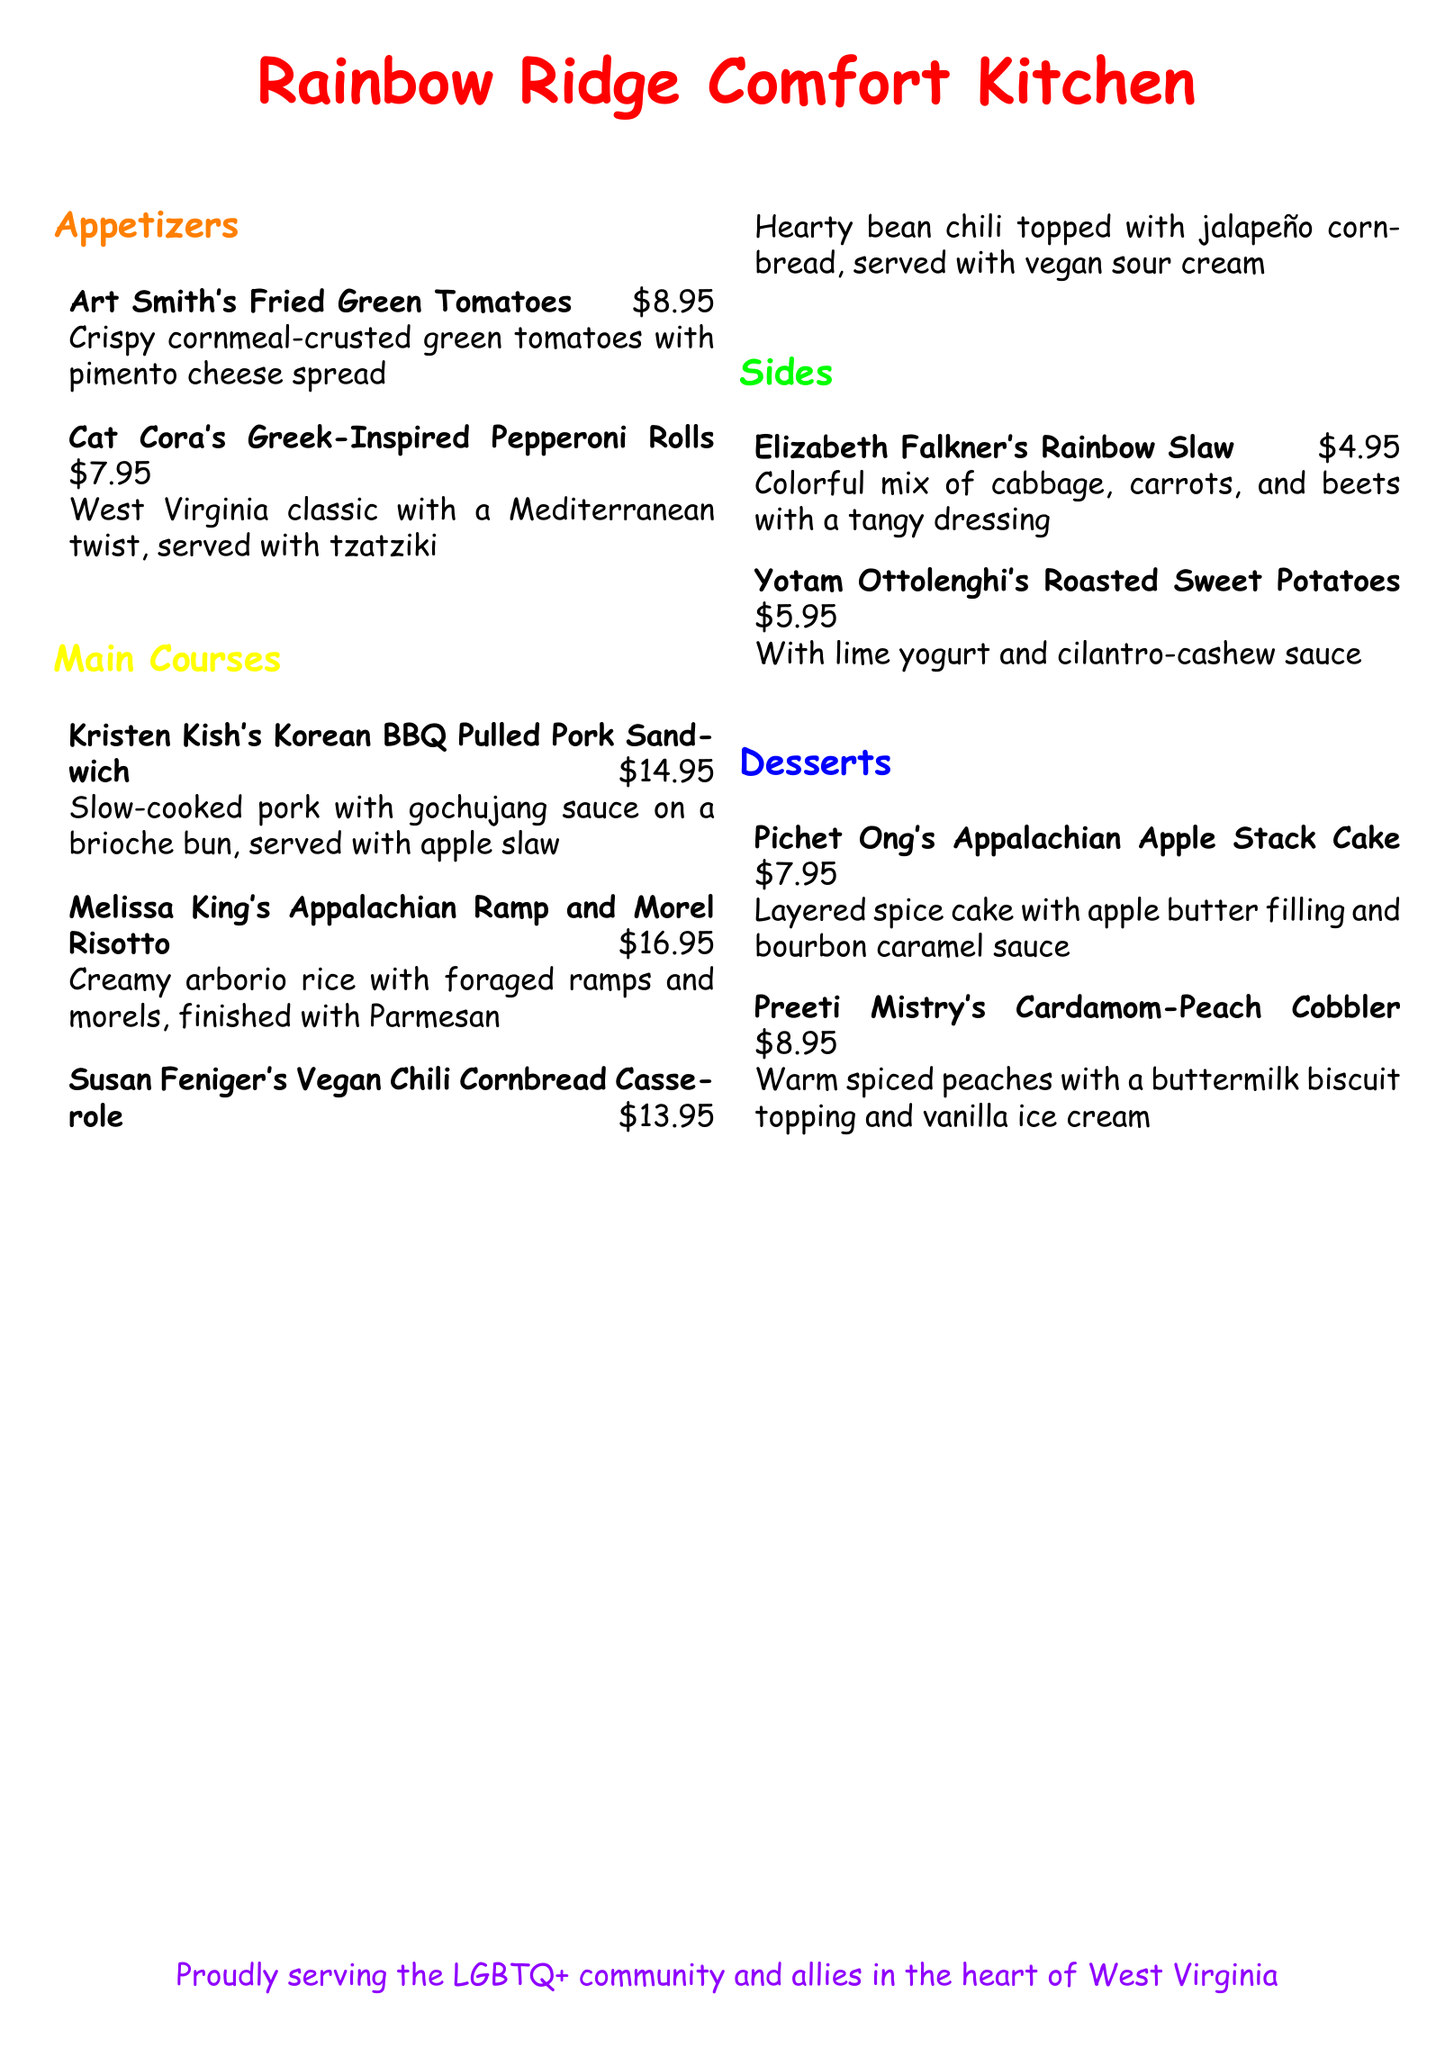what is the name of the restaurant? The name of the restaurant is prominently displayed at the top of the document.
Answer: Rainbow Ridge Comfort Kitchen how much is Susan Feniger's Vegan Chili Cornbread Casserole? The price is listed next to the dish description in the main courses section.
Answer: $13.95 who is the chef for the Roasted Sweet Potatoes? The chef's name is associated with the dish in the sides section of the menu.
Answer: Yotam Ottolenghi what type of sauce is used in Kristen Kish's Pulled Pork Sandwich? The type of sauce is mentioned in the dish description.
Answer: gochujang sauce which dessert features a buttermilk biscuit topping? The dessert listing describes the dish's topping, indicating what it features.
Answer: Cardamom-Peach Cobbler how many types of appetizers are listed on the menu? The number of specific items is determined by counting each item in the appetizers section.
Answer: 2 what is served with the Appalachian Apple Stack Cake? The description of the dessert indicates what is paired with it.
Answer: bourbon caramel sauce which dish is inspired by a West Virginia classic? This dish specifically mentions a cultural reference in its title.
Answer: Greek-Inspired Pepperoni Rolls what color is the headline for the Main Courses section? The color of the headline is specified in the document.
Answer: rainbowyellow 